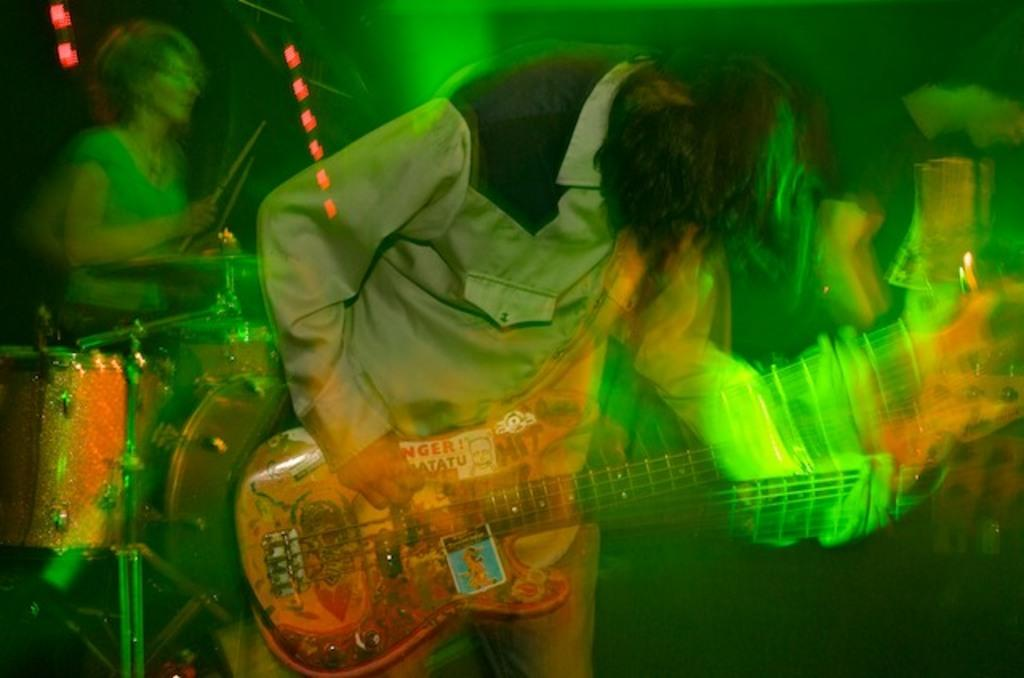What is the main activity being performed by the people in the image? The people in the image are playing musical instruments. Can you describe the specific instruments being played? One person is holding musical instruments, while another person is playing drums. What can be seen in the background of the image? There are green color lights visible in the background of the image. What word is being spelled out by the marbles in the image? There are no marbles present in the image, so no word can be spelled out by them. 